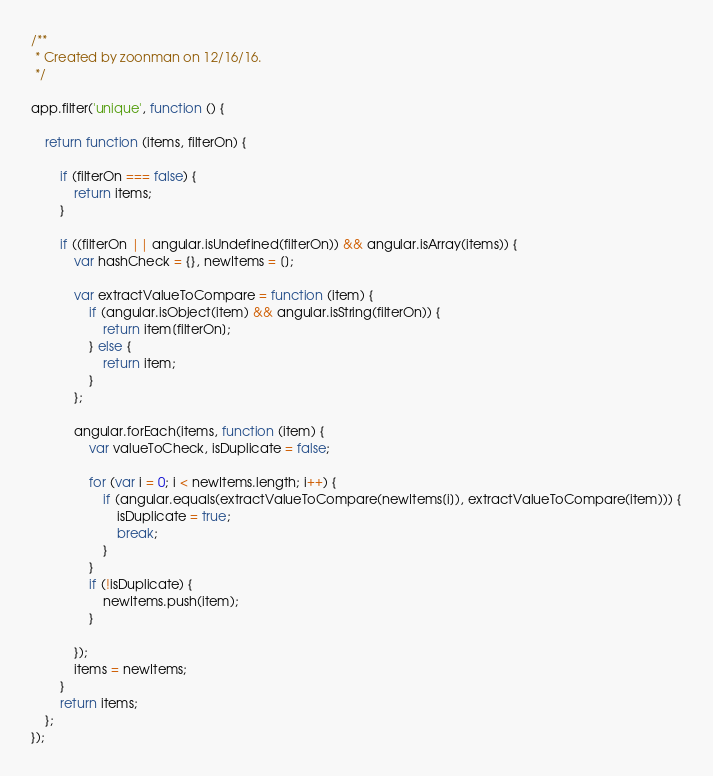<code> <loc_0><loc_0><loc_500><loc_500><_JavaScript_>/**
 * Created by zoonman on 12/16/16.
 */

app.filter('unique', function () {

    return function (items, filterOn) {

        if (filterOn === false) {
            return items;
        }

        if ((filterOn || angular.isUndefined(filterOn)) && angular.isArray(items)) {
            var hashCheck = {}, newItems = [];

            var extractValueToCompare = function (item) {
                if (angular.isObject(item) && angular.isString(filterOn)) {
                    return item[filterOn];
                } else {
                    return item;
                }
            };

            angular.forEach(items, function (item) {
                var valueToCheck, isDuplicate = false;

                for (var i = 0; i < newItems.length; i++) {
                    if (angular.equals(extractValueToCompare(newItems[i]), extractValueToCompare(item))) {
                        isDuplicate = true;
                        break;
                    }
                }
                if (!isDuplicate) {
                    newItems.push(item);
                }

            });
            items = newItems;
        }
        return items;
    };
});
</code> 